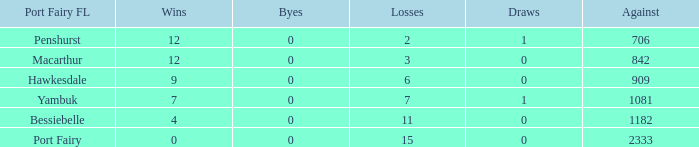How many draws when the Port Fairy FL is Hawkesdale and there are more than 9 wins? None. 